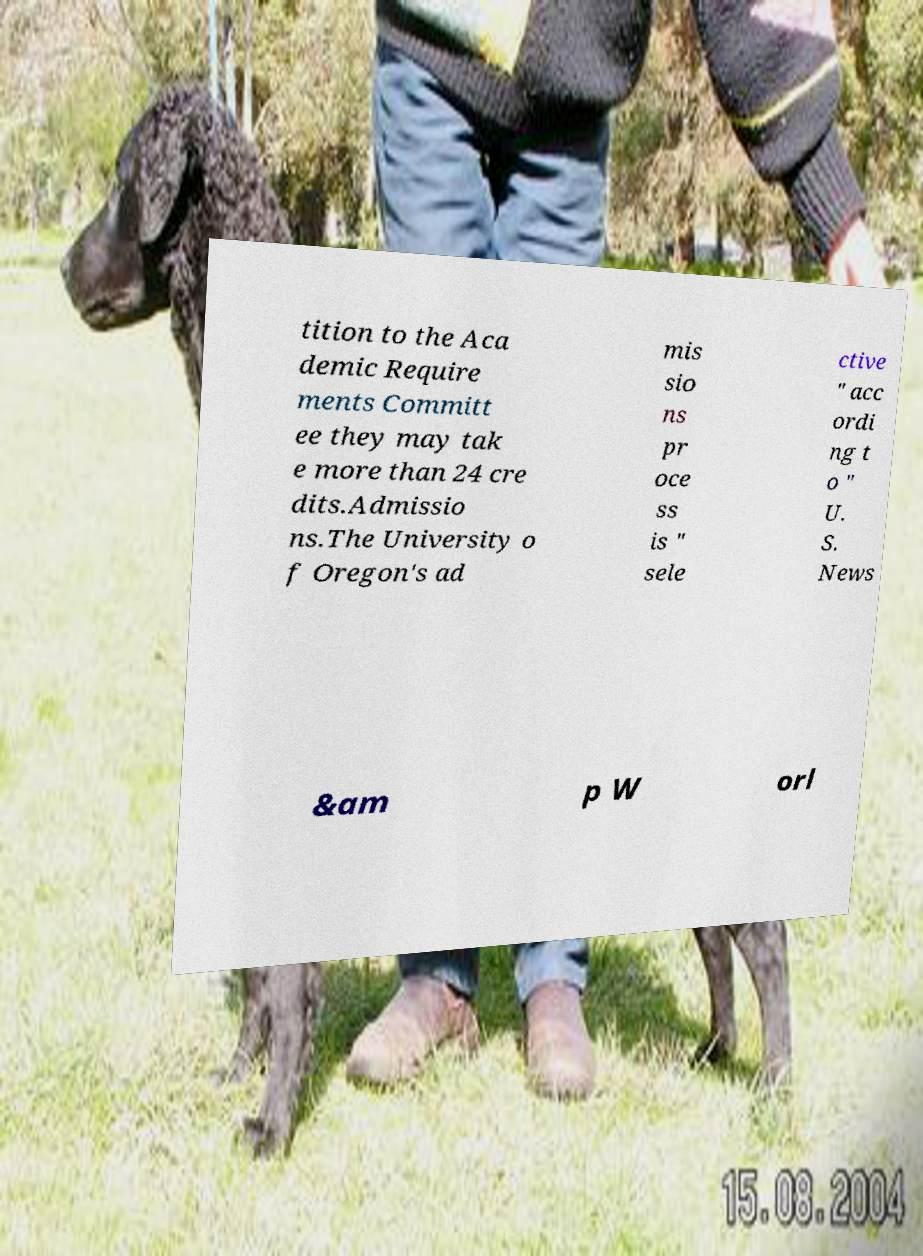I need the written content from this picture converted into text. Can you do that? tition to the Aca demic Require ments Committ ee they may tak e more than 24 cre dits.Admissio ns.The University o f Oregon's ad mis sio ns pr oce ss is " sele ctive " acc ordi ng t o " U. S. News &am p W orl 